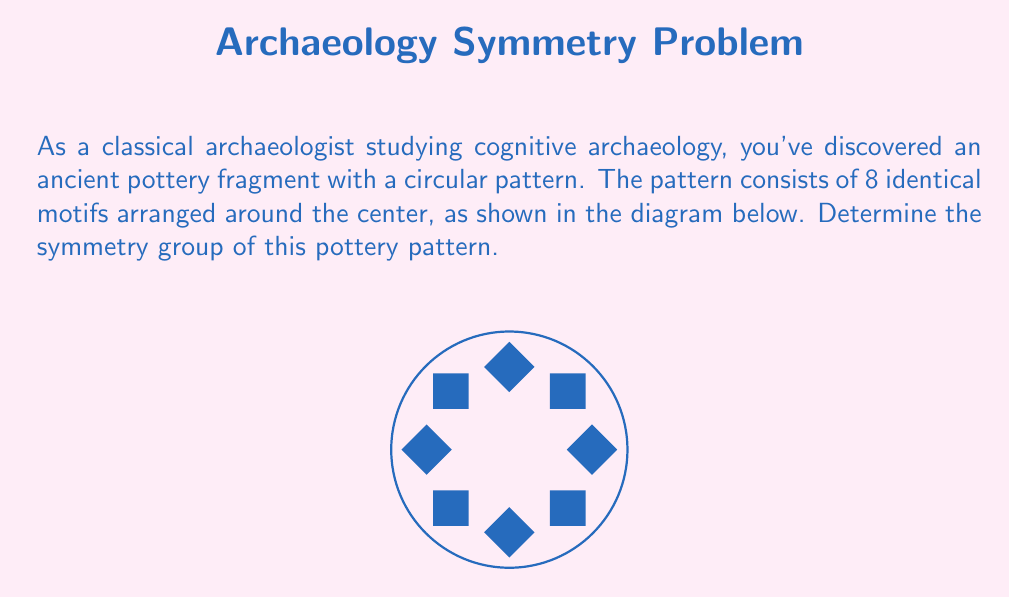Help me with this question. To determine the symmetry group of this pottery pattern, we need to identify all the symmetry operations that leave the pattern unchanged:

1. Rotational symmetry:
   - The pattern is unchanged when rotated by multiples of 45°.
   - There are 8 rotational symmetries: 0°, 45°, 90°, 135°, 180°, 225°, 270°, 315°.

2. Reflection symmetry:
   - The pattern has 8 lines of reflection: 4 through the motifs and 4 between the motifs.

3. Identity:
   - The identity transformation (no change) is always a symmetry.

These symmetries form the dihedral group $D_8$, which has order 16.

The elements of $D_8$ can be represented as:
$$D_8 = \{e, r, r^2, r^3, r^4, r^5, r^6, r^7, s, sr, sr^2, sr^3, sr^4, sr^5, sr^6, sr^7\}$$

Where:
- $e$ is the identity
- $r$ is a rotation by 45°
- $s$ is a reflection

The group operation table for $D_8$ would be a 16x16 table showing how these elements combine.

This group is isomorphic to the symmetries of a regular octagon, which matches the 8-fold symmetry of the pottery pattern.
Answer: $D_8$ 